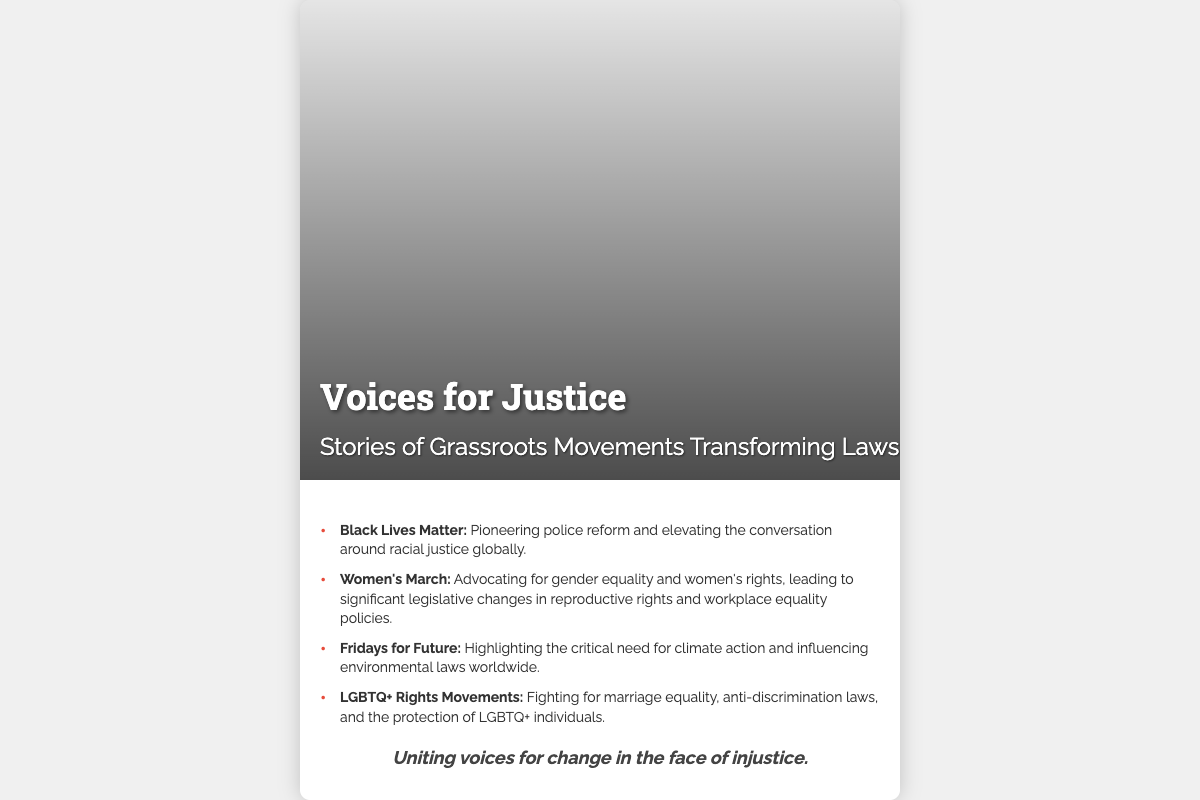What is the title of the book? The title of the book is presented prominently at the top of the cover in large font.
Answer: Voices for Justice Who authored the book? The document does not provide information about the author of the book.
Answer: N/A What is the main focus of the book? The subtitle on the cover gives insight into the book's focus on grassroots movements influencing laws.
Answer: Grassroots Movements Transforming Laws Which prominent movement is associated with police reform? One of the movements mentioned in the list specifically addresses police reform efforts.
Answer: Black Lives Matter What significant issue does the Women's March advocate for? The content indicates that the Women's March focuses on gender equality and rights.
Answer: Gender equality Which global initiative emphasizes climate action? The list includes a movement that highlights the urgent need for climate-related actions.
Answer: Fridays for Future How many movements are highlighted in the document? The document provides specific details about four distinct movements.
Answer: Four What is the tagline of the book? The tagline is a concise phrase encompassing the book's theme, found at the bottom of the content area.
Answer: Uniting voices for change in the face of injustice What visual element is featured on the cover? The cover prominently displays a specific type of visual element that reflects the book's theme.
Answer: Mosaic of diverse faces in protest 